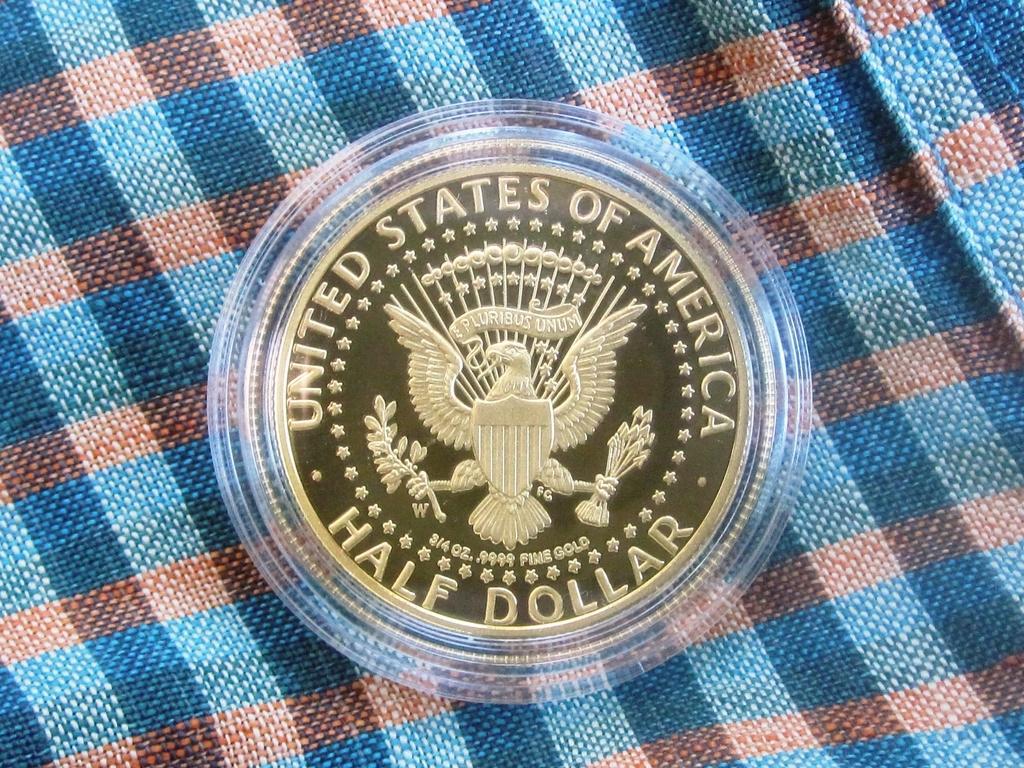Can you describe this image briefly? In this image I can see a coin on the cloth and the cloth is in blue and brown color. 